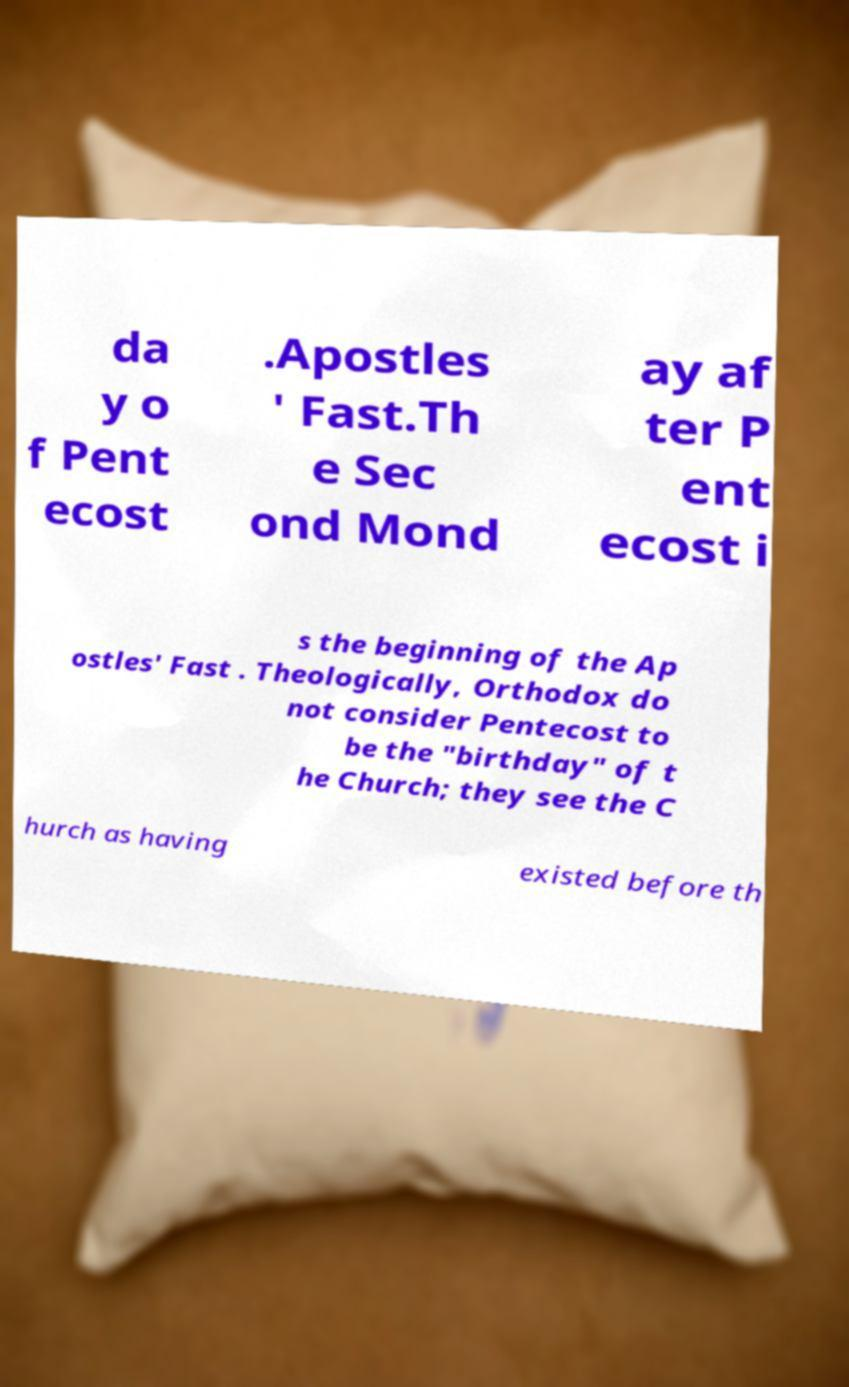I need the written content from this picture converted into text. Can you do that? da y o f Pent ecost .Apostles ' Fast.Th e Sec ond Mond ay af ter P ent ecost i s the beginning of the Ap ostles' Fast . Theologically, Orthodox do not consider Pentecost to be the "birthday" of t he Church; they see the C hurch as having existed before th 